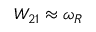<formula> <loc_0><loc_0><loc_500><loc_500>W _ { 2 1 } \approx \omega _ { R }</formula> 